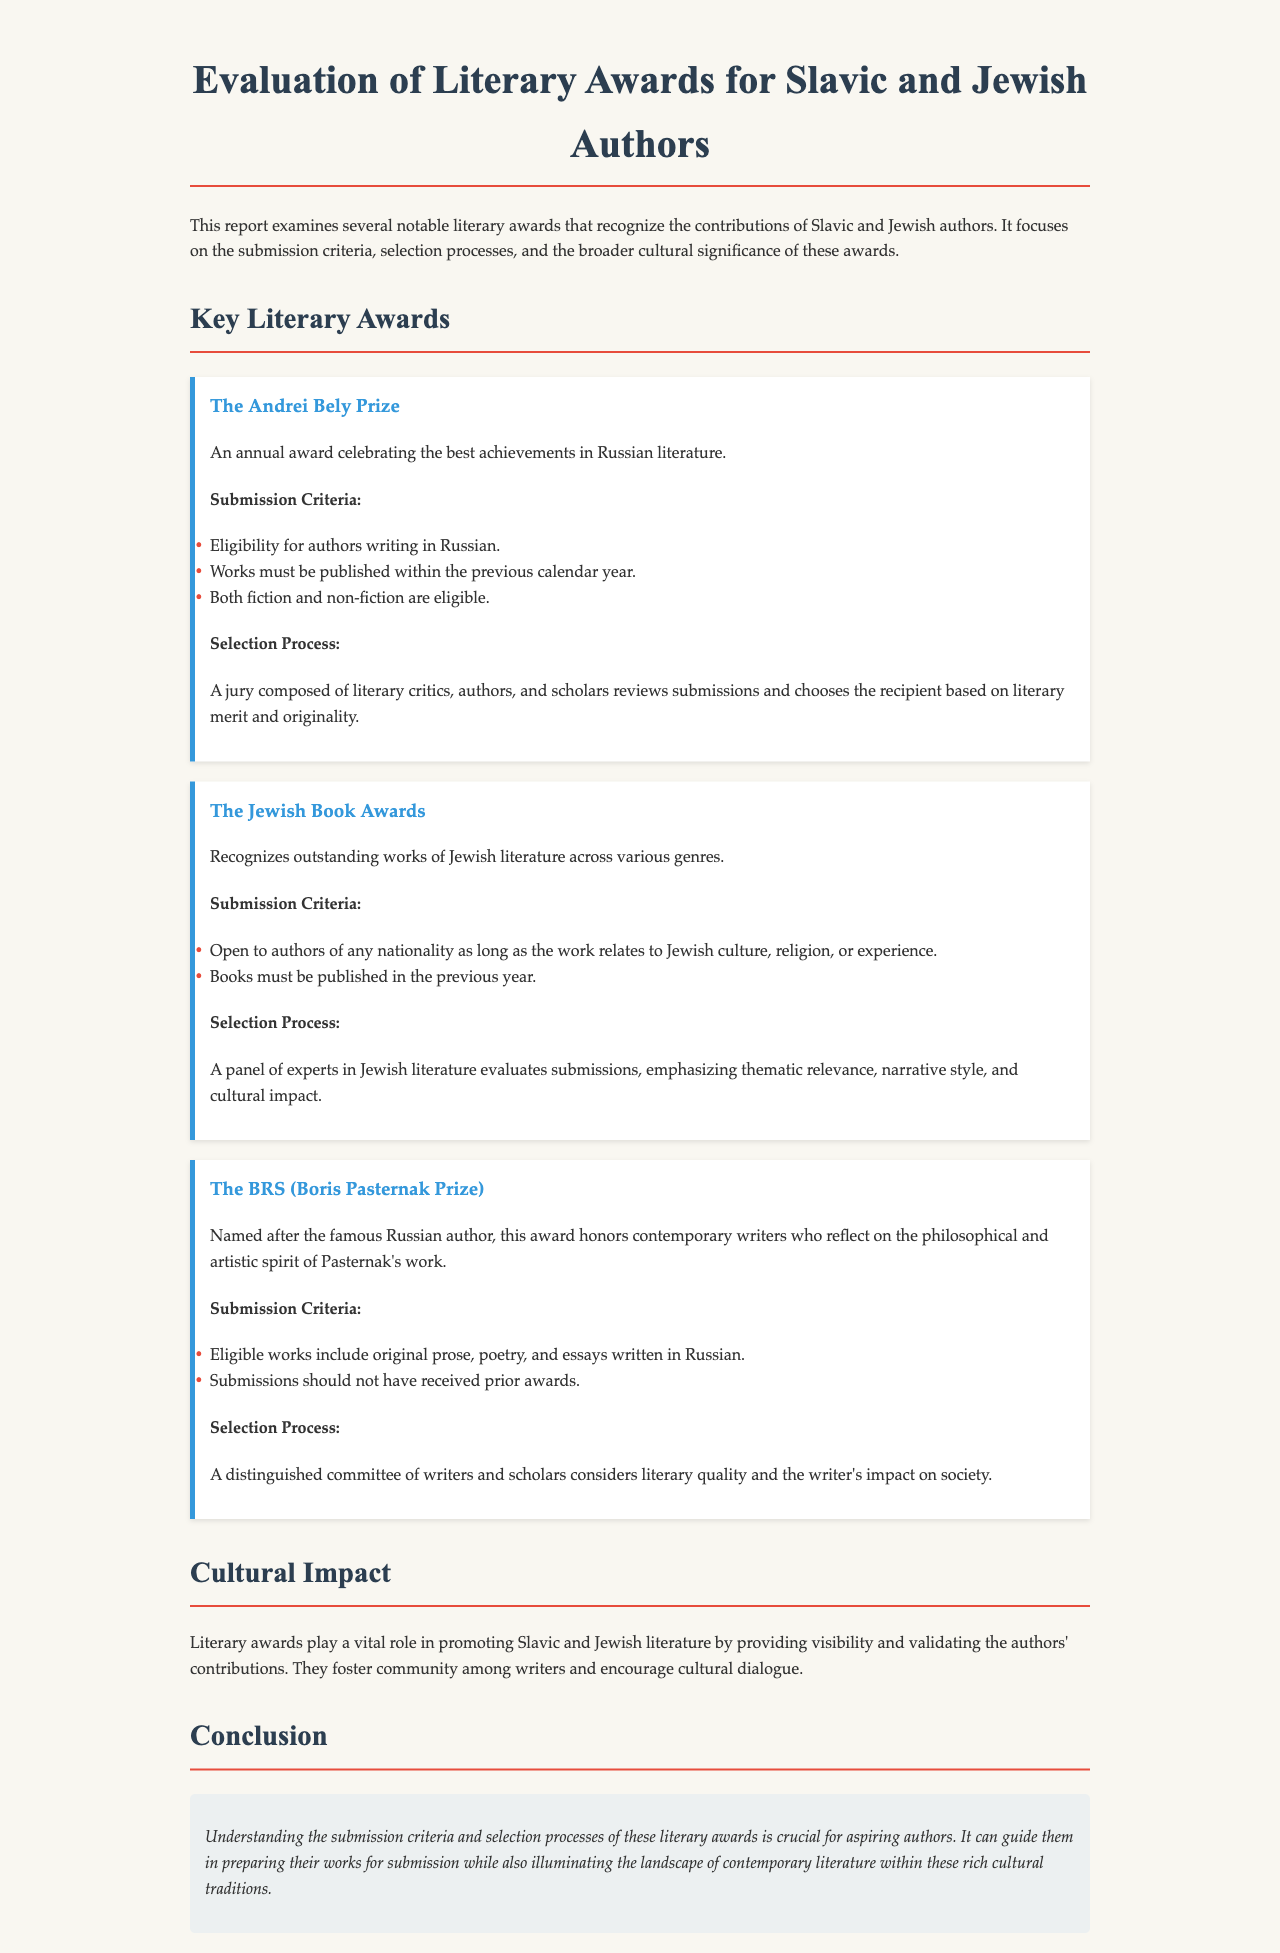What is the Andrei Bely Prize? The Andrei Bely Prize is an annual award celebrating the best achievements in Russian literature.
Answer: An annual award celebrating the best achievements in Russian literature What are the submission criteria for The Jewish Book Awards? The submission criteria includes that works must relate to Jewish culture, religion, or experience and must be published in the previous year.
Answer: Open to authors of any nationality as long as the work relates to Jewish culture, religion, or experience; books must be published in the previous year How many years of publication are required for the submissions of The BRS Prize? The criteria state that submissions should be works published within the previous calendar year.
Answer: Previous calendar year What is the primary focus of the selection process for The Jewish Book Awards? The selection process focuses on thematic relevance, narrative style, and cultural impact as evaluated by a panel of experts.
Answer: Thematic relevance, narrative style, and cultural impact Who evaluates submissions for The Andrei Bely Prize? A jury composed of literary critics, authors, and scholars reviews the submissions.
Answer: A jury of literary critics, authors, and scholars What literary forms are eligible for The BRS Prize? Eligible works include original prose, poetry, and essays written in Russian.
Answer: Original prose, poetry, and essays 